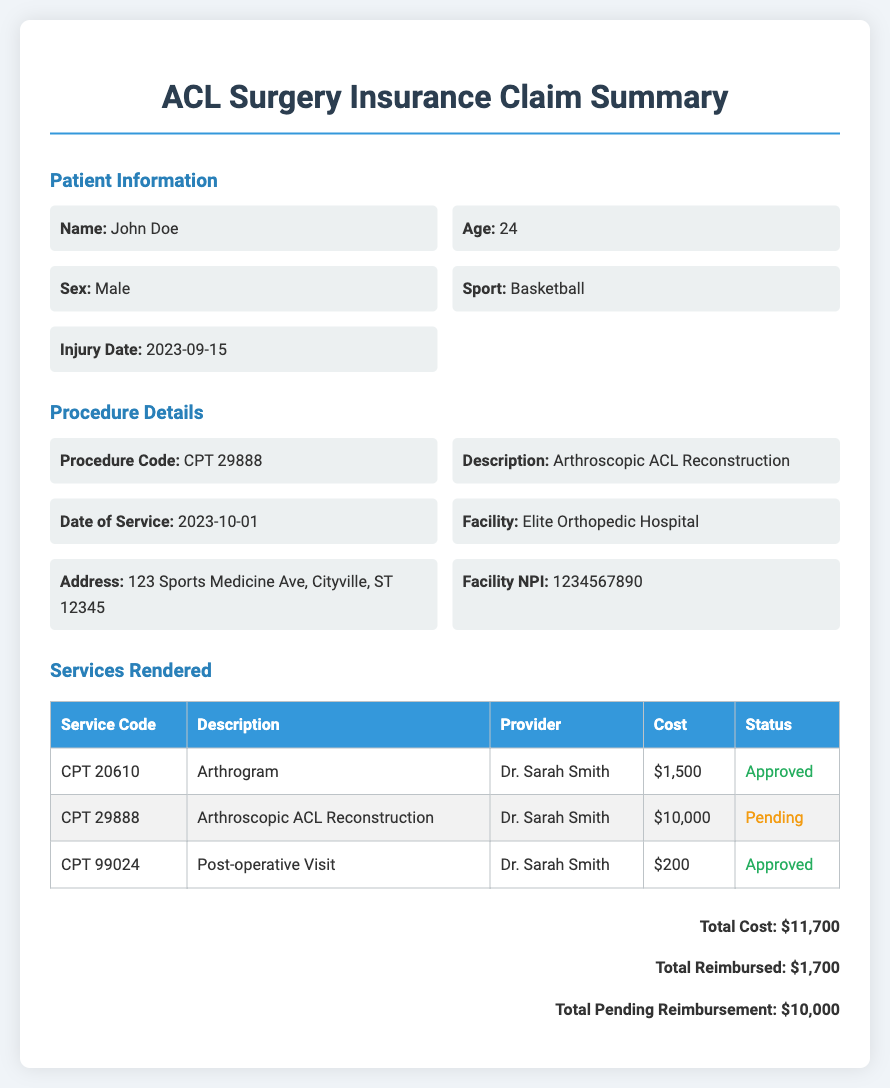What is the patient's name? The document provides the patient's name as John Doe.
Answer: John Doe What is the procedure code? The procedure code listed in the document is 29888.
Answer: CPT 29888 What is the total cost of services rendered? The total cost of services rendered is calculated as the sum of all service costs, which is $11,700.
Answer: $11,700 Who performed the surgery? The doctor who performed the surgery is identified as Dr. Sarah Smith.
Answer: Dr. Sarah Smith What is the reimbursement status of the Arthroscopic ACL Reconstruction? The document indicates that the reimbursement status of the Arthroscopic ACL Reconstruction is pending.
Answer: Pending How much has been reimbursed so far? The amount reimbursed to date is mentioned as $1,700.
Answer: $1,700 Where did the procedure take place? The facility where the procedure took place is Elite Orthopedic Hospital.
Answer: Elite Orthopedic Hospital What is the date of service for the procedure? The date of service for the procedure is stated as October 1, 2023.
Answer: 2023-10-01 What is the total pending reimbursement? The document specifies that the total pending reimbursement is $10,000.
Answer: $10,000 